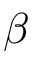Convert formula to latex. <formula><loc_0><loc_0><loc_500><loc_500>\beta</formula> 